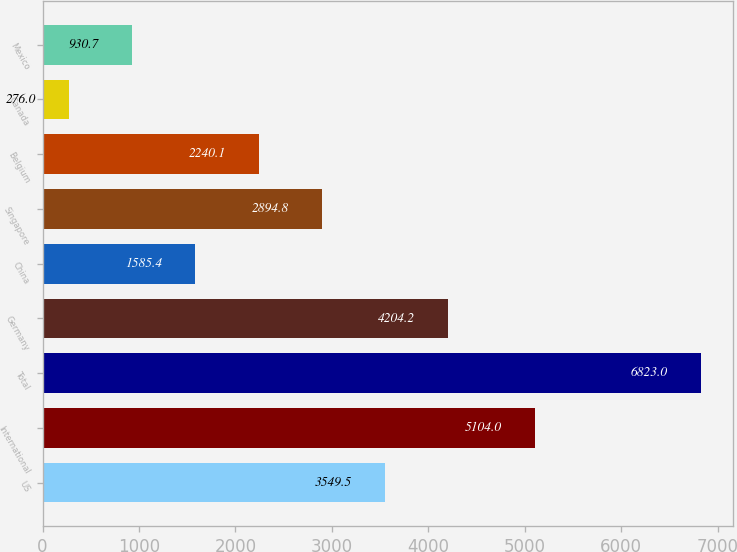Convert chart. <chart><loc_0><loc_0><loc_500><loc_500><bar_chart><fcel>US<fcel>International<fcel>Total<fcel>Germany<fcel>China<fcel>Singapore<fcel>Belgium<fcel>Canada<fcel>Mexico<nl><fcel>3549.5<fcel>5104<fcel>6823<fcel>4204.2<fcel>1585.4<fcel>2894.8<fcel>2240.1<fcel>276<fcel>930.7<nl></chart> 